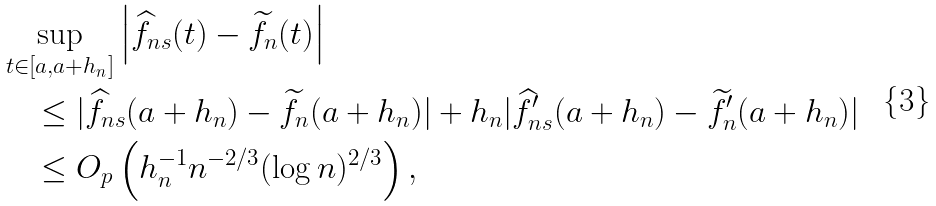<formula> <loc_0><loc_0><loc_500><loc_500>& \sup _ { t \in [ a , a + h _ { n } ] } \left | \widehat { f } _ { n s } ( t ) - \widetilde { f } _ { n } ( t ) \right | \\ & \quad \leq | \widehat { f } _ { n s } ( a + h _ { n } ) - \widetilde { f } _ { n } ( a + h _ { n } ) | + h _ { n } | \widehat { f } _ { n s } ^ { \prime } ( a + h _ { n } ) - \widetilde { f } _ { n } ^ { \prime } ( a + h _ { n } ) | \\ & \quad \leq O _ { p } \left ( h _ { n } ^ { - 1 } n ^ { - 2 / 3 } ( \log n ) ^ { 2 / 3 } \right ) ,</formula> 